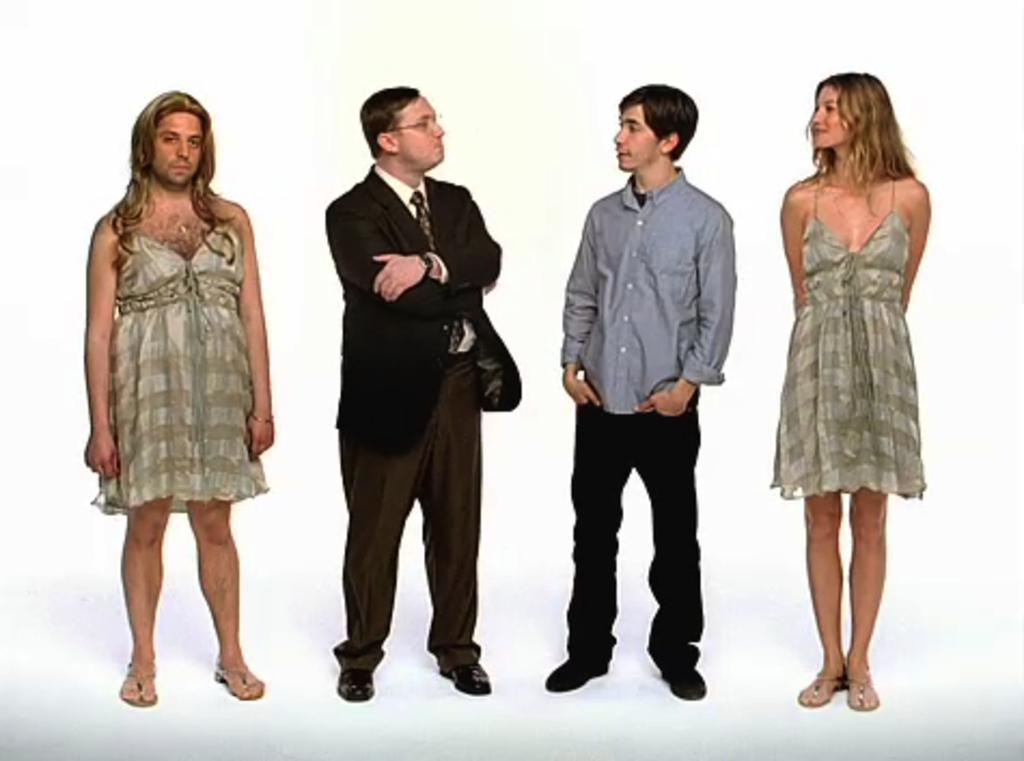How many people are visible in the image? There are people standing in the image, but the exact number cannot be determined without more information. What are the people in the image doing? The provided facts do not specify what the people are doing in the image. Can you describe the setting or environment in which the people are standing? The provided facts do not give any information about the setting or environment in which the people are standing. What type of grain is being harvested by the people in the image? There is no information about grain or harvesting in the provided facts, and the image does not show any grain or harvesting activity. 